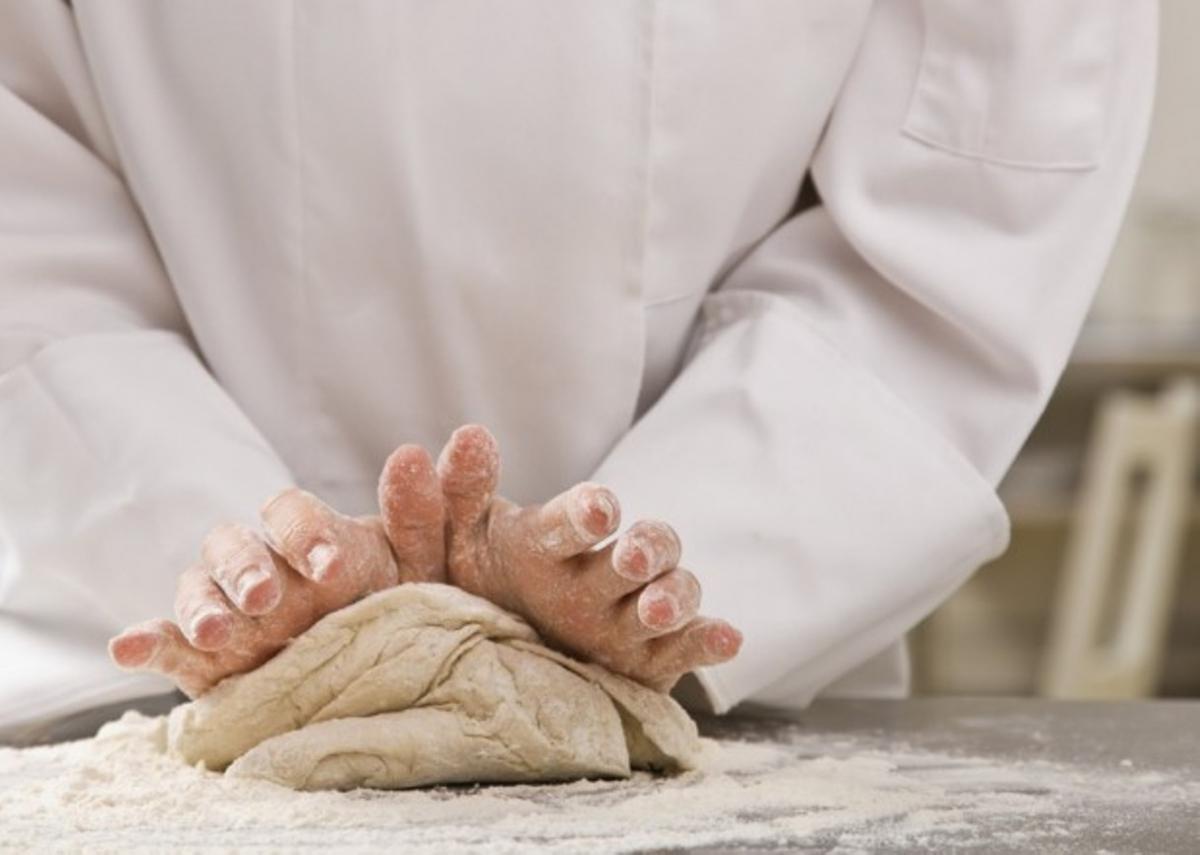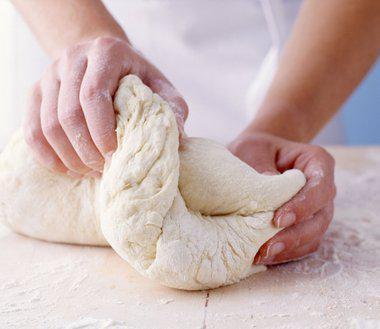The first image is the image on the left, the second image is the image on the right. Evaluate the accuracy of this statement regarding the images: "A person is shaping dough by hand.". Is it true? Answer yes or no. Yes. The first image is the image on the left, the second image is the image on the right. Analyze the images presented: Is the assertion "One and only one of the two images has hands in it." valid? Answer yes or no. No. 